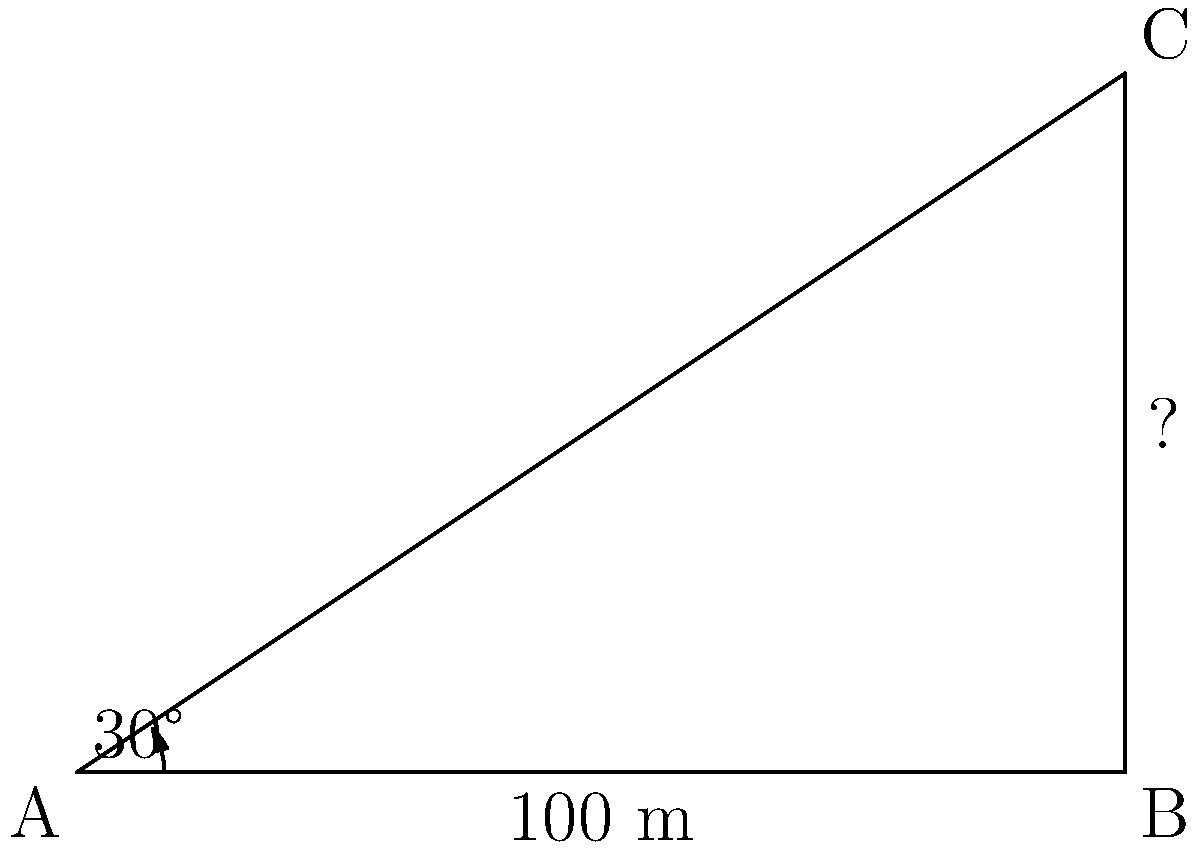In a legal dispute over the placement of a new cell tower, you need to determine its height for compliance with local regulations. From a point A on the ground, you measure the angle of elevation to the top of the tower (point C) to be 30°. The distance from point A to the base of the tower (point B) is 100 meters. What is the height of the cell tower to the nearest meter? To solve this problem, we'll use trigonometric ratios, specifically the tangent function. Let's approach this step-by-step:

1) In the right triangle ABC, we know:
   - The angle at A is 30°
   - The adjacent side (AB) is 100 meters
   - We need to find the opposite side (BC), which represents the height of the tower

2) The tangent of an angle in a right triangle is the ratio of the opposite side to the adjacent side:

   $$\tan \theta = \frac{\text{opposite}}{\text{adjacent}}$$

3) In this case:

   $$\tan 30° = \frac{\text{height of tower}}{\text{100 m}}$$

4) We can rearrange this to solve for the height:

   $$\text{height of tower} = 100 \cdot \tan 30°$$

5) Now, let's calculate:
   - $\tan 30° \approx 0.5773$ (using a calculator or trigonometric tables)

6) Therefore:

   $$\text{height of tower} = 100 \cdot 0.5773 \approx 57.73 \text{ meters}$$

7) Rounding to the nearest meter:

   $$\text{height of tower} \approx 58 \text{ meters}$$

This height could be crucial in determining whether the cell tower complies with local zoning laws or telecommunications regulations.
Answer: 58 meters 